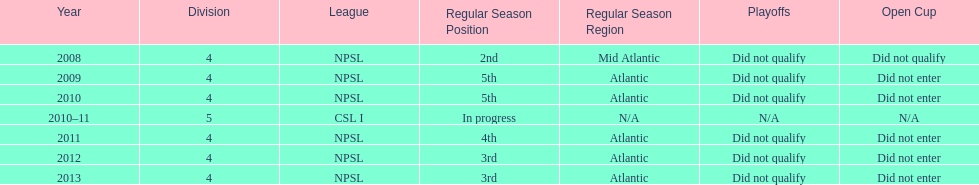In what year only did they compete in division 5 2010-11. 